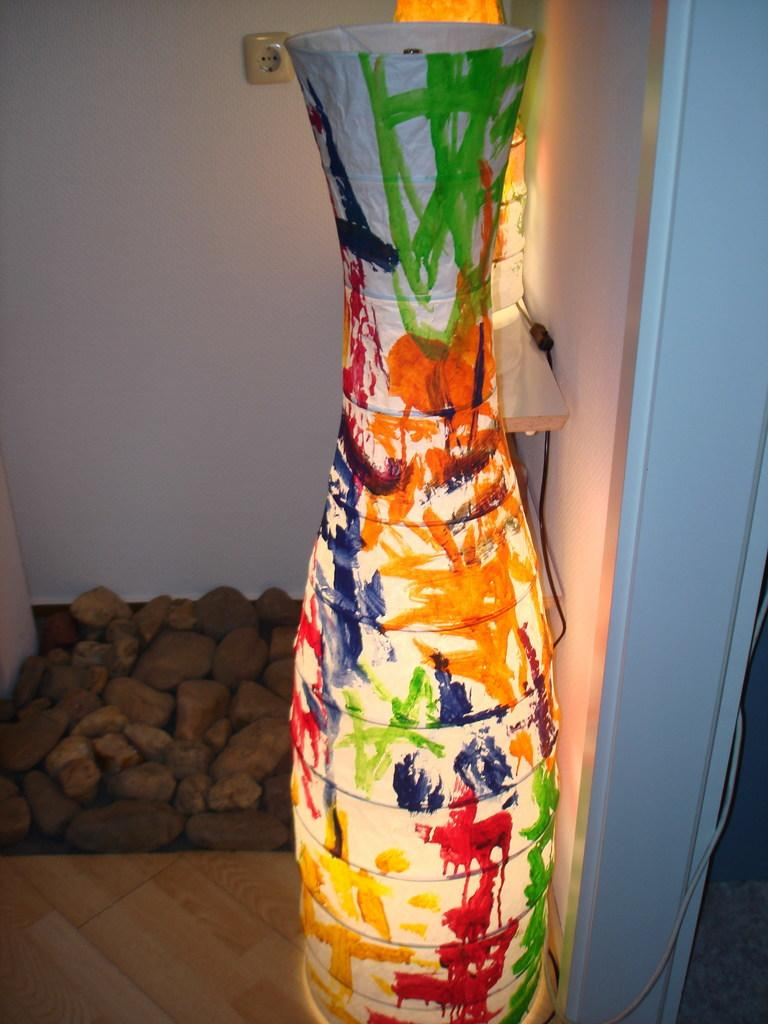What can be seen in the image that provides illumination? There is light in the image. What type of structure is present in the image? There is a wall in the image. What type of natural material is visible in the image? There are stones in the image. How does the digestion process work for the stones in the image? There are no living organisms or digestion processes present in the image, as it only features stones, light, and a wall. What type of cart is used to transport the light in the image? There is no cart present in the image, and the light is not being transported. 